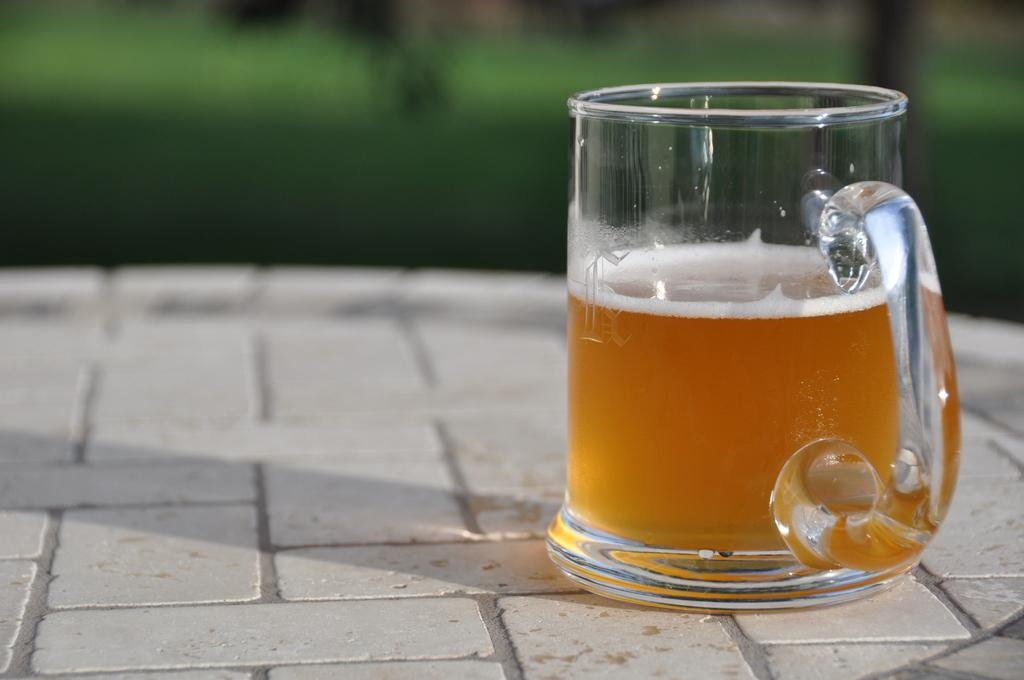What object is in the foreground of the picture? There is a mug in the foreground of the picture. What is inside the mug? The mug contains beer. Can you describe the background of the image? The background of the image is blurred. What is the afterthought of the person holding the mug in the image? There is no indication of an afterthought in the image, as it only shows a mug containing beer and a blurred background. 